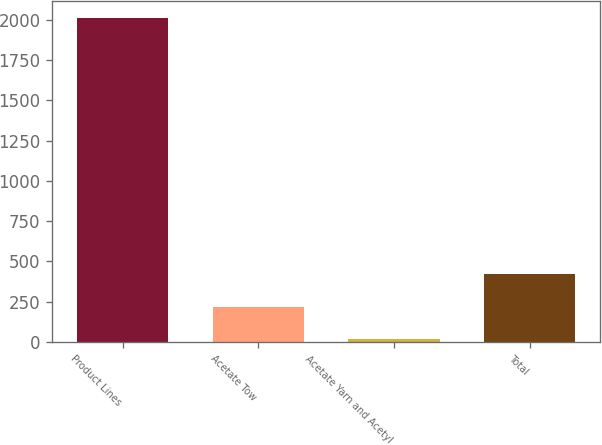Convert chart. <chart><loc_0><loc_0><loc_500><loc_500><bar_chart><fcel>Product Lines<fcel>Acetate Tow<fcel>Acetate Yarn and Acetyl<fcel>Total<nl><fcel>2014<fcel>220.3<fcel>21<fcel>419.6<nl></chart> 